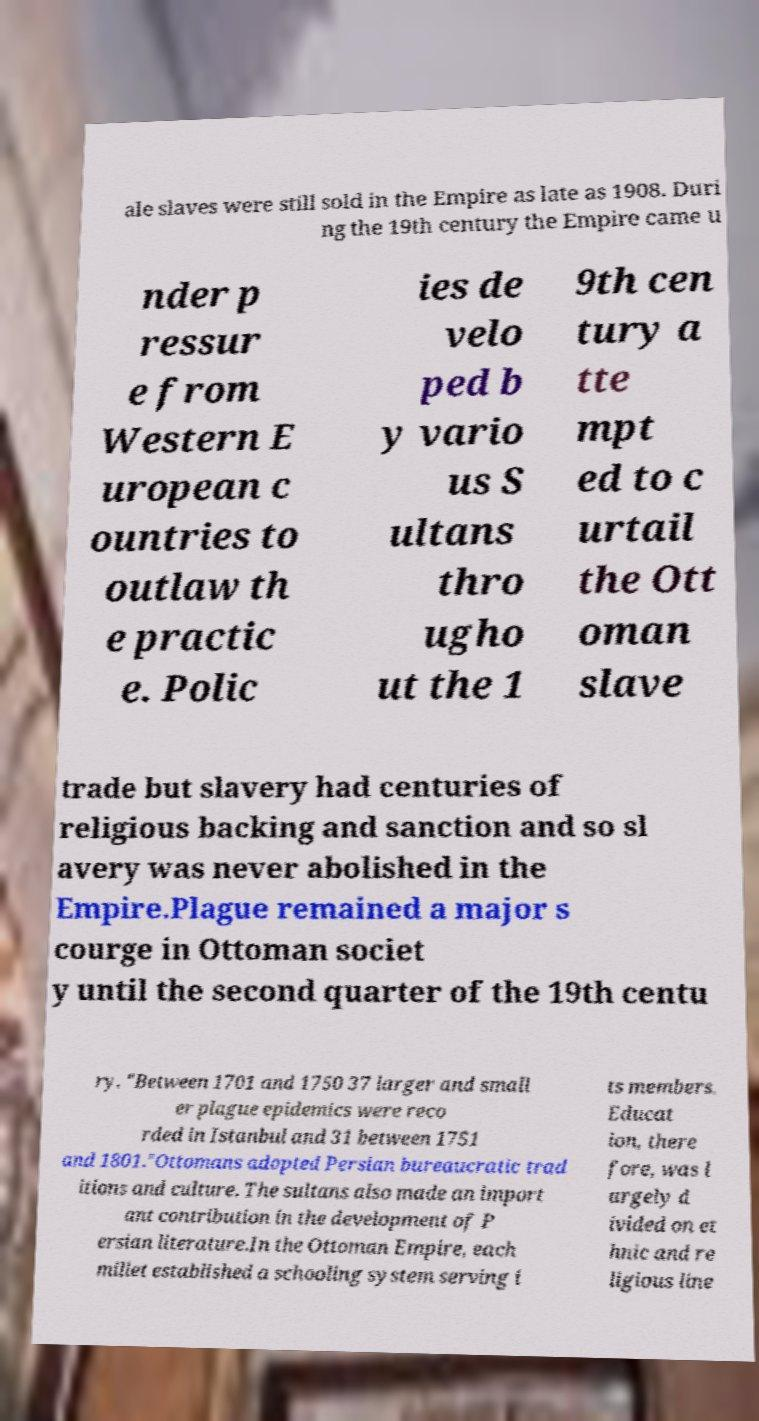What messages or text are displayed in this image? I need them in a readable, typed format. ale slaves were still sold in the Empire as late as 1908. Duri ng the 19th century the Empire came u nder p ressur e from Western E uropean c ountries to outlaw th e practic e. Polic ies de velo ped b y vario us S ultans thro ugho ut the 1 9th cen tury a tte mpt ed to c urtail the Ott oman slave trade but slavery had centuries of religious backing and sanction and so sl avery was never abolished in the Empire.Plague remained a major s courge in Ottoman societ y until the second quarter of the 19th centu ry. "Between 1701 and 1750 37 larger and small er plague epidemics were reco rded in Istanbul and 31 between 1751 and 1801."Ottomans adopted Persian bureaucratic trad itions and culture. The sultans also made an import ant contribution in the development of P ersian literature.In the Ottoman Empire, each millet established a schooling system serving i ts members. Educat ion, there fore, was l argely d ivided on et hnic and re ligious line 